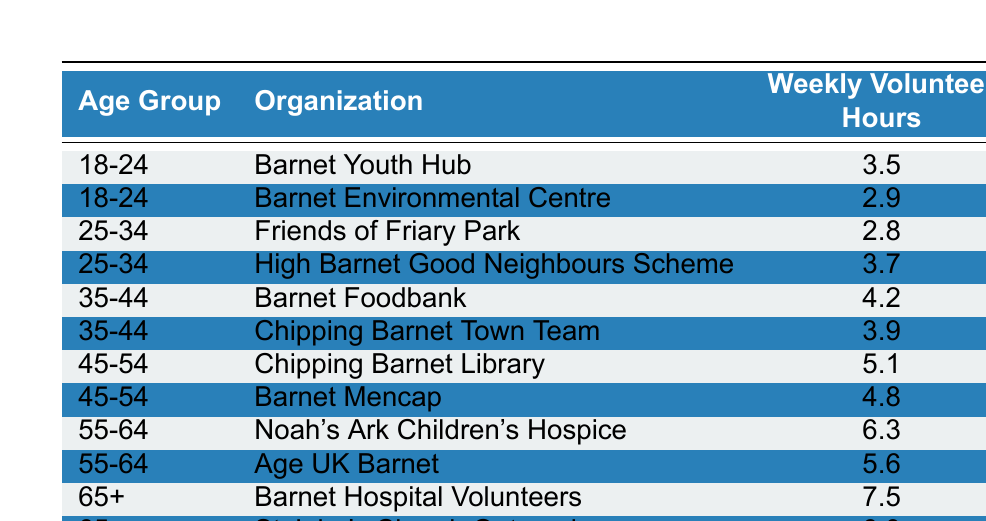What is the weekly volunteer hour contribution for the age group 45-54? According to the table, the weekly volunteer hour contribution for the age group 45-54 is listed as 5.1 hours from Chipping Barnet Library and 4.8 hours from Barnet Mencap.
Answer: 5.1 and 4.8 hours Which age group has the highest total weekly volunteer hours? To determine this, we sum the weekly volunteer hours for each age group. For 65+: 7.5 + 6.9 = 14.4; for 55-64: 6.3 + 5.6 = 11.9; for 45-54: 5.1 + 4.8 = 9.9; for 35-44: 4.2 + 3.9 = 8.1; for 25-34: 2.8 + 3.7 = 6.5; for 18-24: 3.5 + 2.9 = 6.4. The age group 65+ has the highest total of 14.4 hours.
Answer: 65+ Is there any age group where both organizations have contributed an equal number of weekly volunteer hours? By examining the table, we see that the age groups 35-44 and 45-54 have different contributions from their organizations (4.2 and 4.8 respectively from Barnet Foodbank and Chipping Barnet Library). Thus, there is no age group where both organizations contributed equally.
Answer: No What is the difference in weekly volunteer hours between the age groups 55-64 and 25-34? For the age group 55-64, the total weekly volunteer hours are 6.3 + 5.6 = 11.9, while for 25-34 they are 2.8 + 3.7 = 6.5. The difference is 11.9 - 6.5 = 5.4 hours.
Answer: 5.4 hours Which organization contributes the most weekly volunteer hours in the age group 65+? The age group 65+ has two organizations: Barnet Hospital Volunteers contributing 7.5 hours and St John's Church Outreach contributing 6.9 hours. Comparing these, Barnet Hospital Volunteers contributes the most.
Answer: Barnet Hospital Volunteers What is the average weekly volunteer hours contributed by the age group 18-24? The age group 18-24 has two contributions: 3.5 hours and 2.9 hours. The average is calculated as (3.5 + 2.9) / 2 = 6.4 / 2 = 3.2 hours.
Answer: 3.2 hours How many total weekly volunteer hours were contributed by the age group 35-44? For the age group 35-44, we have contributions of 4.2 hours from Barnet Foodbank and 3.9 hours from Chipping Barnet Town Team, giving us a total of 4.2 + 3.9 = 8.1 hours.
Answer: 8.1 hours Which age group has a higher average weekly volunteer hour, 45-54 or 55-64? For 45-54, the average is (5.1 + 4.8) / 2 = 9.9 / 2 = 4.95 hours. For 55-64, the average is (6.3 + 5.6) / 2 = 11.9 / 2 = 5.95 hours. Therefore, 55-64 has a higher average.
Answer: 55-64 Are there more weekly volunteer hours contributed by individuals aged 25-34 compared to those aged 18-24? For 25-34, total hours = 2.8 + 3.7 = 6.5; for 18-24, total hours = 3.5 + 2.9 = 6.4. Comparing, 6.5 > 6.4 indicates more hours by 25-34.
Answer: Yes What is the total number of volunteers hours contributed by all age groups? Summing all contributions from the table gives: (3.5 + 2.9) + (2.8 + 3.7) + (4.2 + 3.9) + (5.1 + 4.8) + (6.3 + 5.6) + (7.5 + 6.9) = 55.4 hours.
Answer: 55.4 hours 